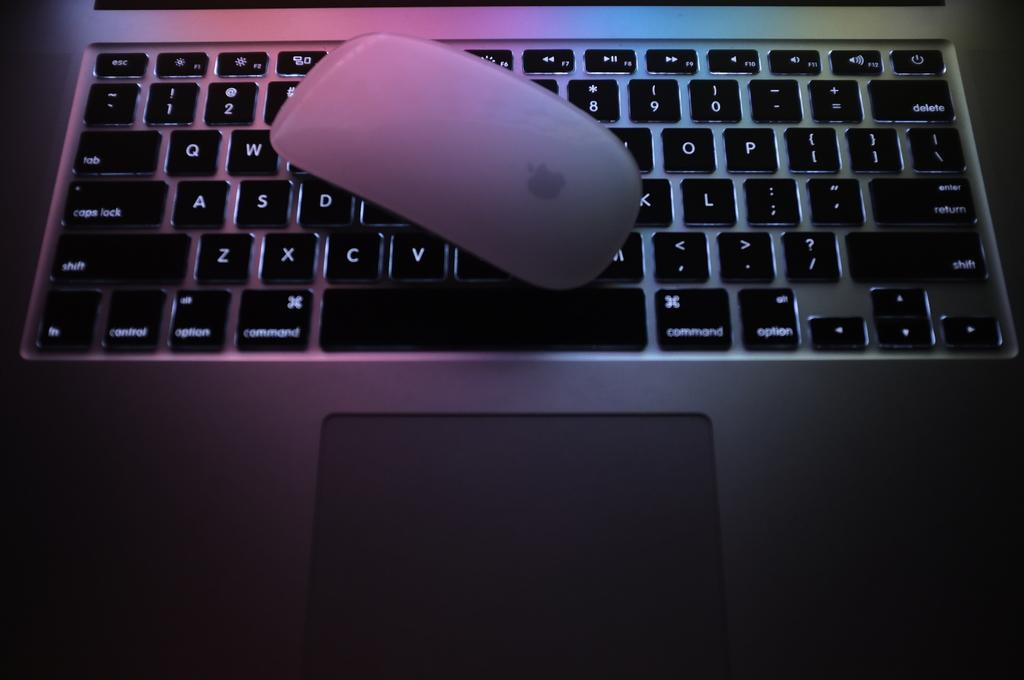<image>
Offer a succinct explanation of the picture presented. Keyboard with a colorful light and the option key next to the command key. 